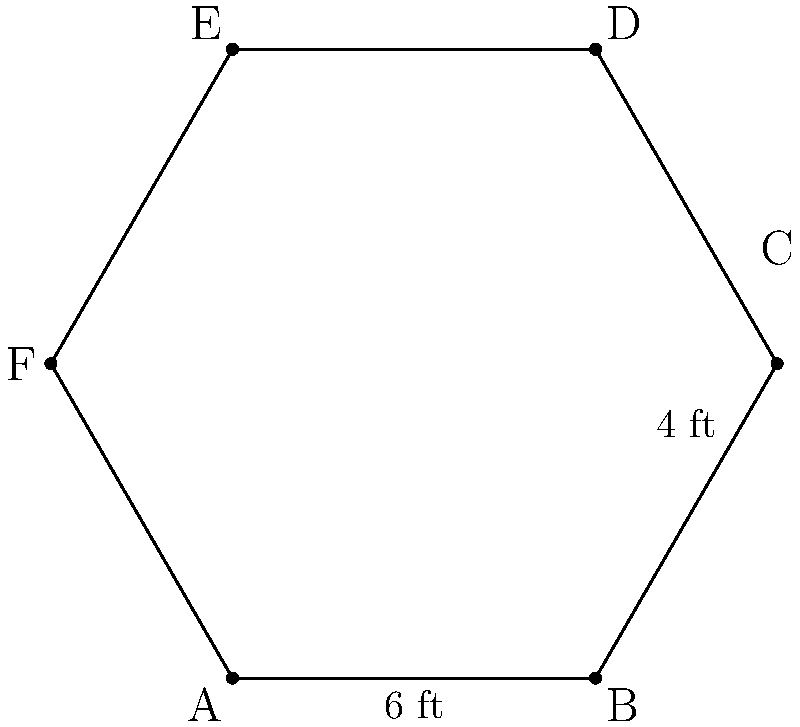As you prepare for your baby's arrival, you're considering purchasing a hexagonal playpen for when they become a toddler. The playpen has the shape of a regular hexagon with a side length of 6 feet. If the distance between any two opposite vertices is 12 feet, what is the area of the playpen in square feet? Round your answer to the nearest whole number. Let's approach this step-by-step:

1) For a regular hexagon, we can divide it into six equilateral triangles.

2) The area of the hexagon will be 6 times the area of one of these triangles.

3) In an equilateral triangle, the height (h) is given by:
   $h = \frac{\sqrt{3}}{2} \cdot s$, where s is the side length.
   
   $h = \frac{\sqrt{3}}{2} \cdot 6 = 3\sqrt{3}$ feet

4) The area of an equilateral triangle is:
   $A_{triangle} = \frac{1}{2} \cdot base \cdot height = \frac{1}{2} \cdot 6 \cdot 3\sqrt{3} = 9\sqrt{3}$ square feet

5) The area of the hexagon is:
   $A_{hexagon} = 6 \cdot A_{triangle} = 6 \cdot 9\sqrt{3} = 54\sqrt{3}$ square feet

6) Calculating this:
   $54\sqrt{3} \approx 93.53$ square feet

7) Rounding to the nearest whole number: 94 square feet

This playpen will provide ample space for your toddler to play safely while you manage your work responsibilities.
Answer: 94 sq ft 